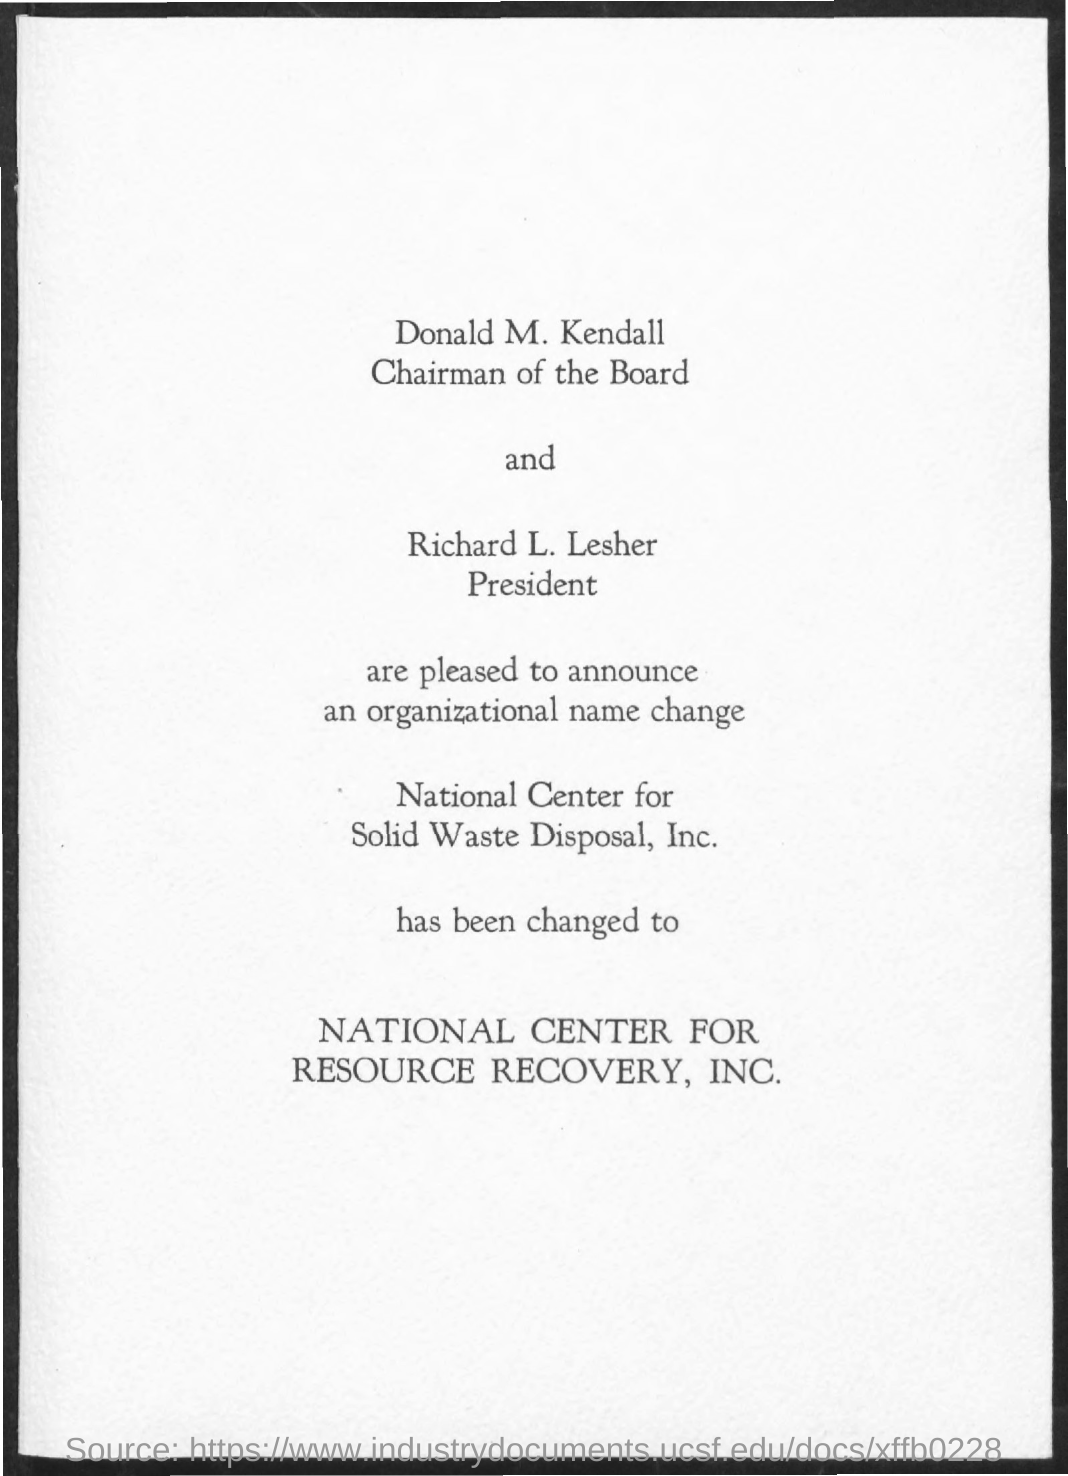Who is the chairman of the board?
Provide a short and direct response. DONALD M. KENDALL. What is the designation of Richard L. Lesher?
Ensure brevity in your answer.  President. What is the organizational name change for National Center for Solid Waste Disposal, Inc.?
Ensure brevity in your answer.  NATIONAL CENTER FOR RESOURCE RECOVERY, INC. 